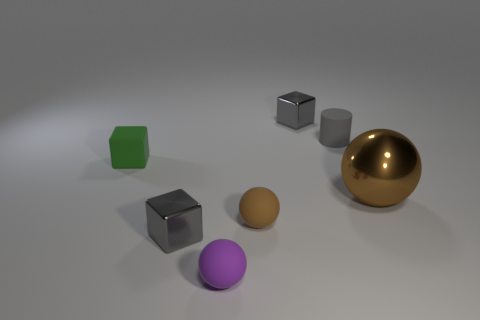What material is the other ball that is the same color as the metallic sphere?
Make the answer very short. Rubber. What number of things are red matte cubes or gray shiny objects that are behind the tiny rubber block?
Your answer should be compact. 1. How many green rubber objects are the same shape as the purple matte object?
Offer a terse response. 0. What material is the green block that is the same size as the brown matte thing?
Your answer should be very brief. Rubber. There is a block that is in front of the big brown object that is on the right side of the tiny brown matte ball that is on the right side of the purple sphere; what is its size?
Offer a very short reply. Small. There is a tiny sphere to the right of the purple matte sphere; is it the same color as the thing behind the gray cylinder?
Provide a short and direct response. No. What number of brown objects are tiny rubber things or tiny objects?
Offer a very short reply. 1. What number of red shiny blocks are the same size as the gray matte cylinder?
Your answer should be very brief. 0. Is the gray block that is in front of the tiny green thing made of the same material as the big brown sphere?
Offer a very short reply. Yes. There is a metallic thing behind the green cube; are there any cylinders that are in front of it?
Offer a very short reply. Yes. 